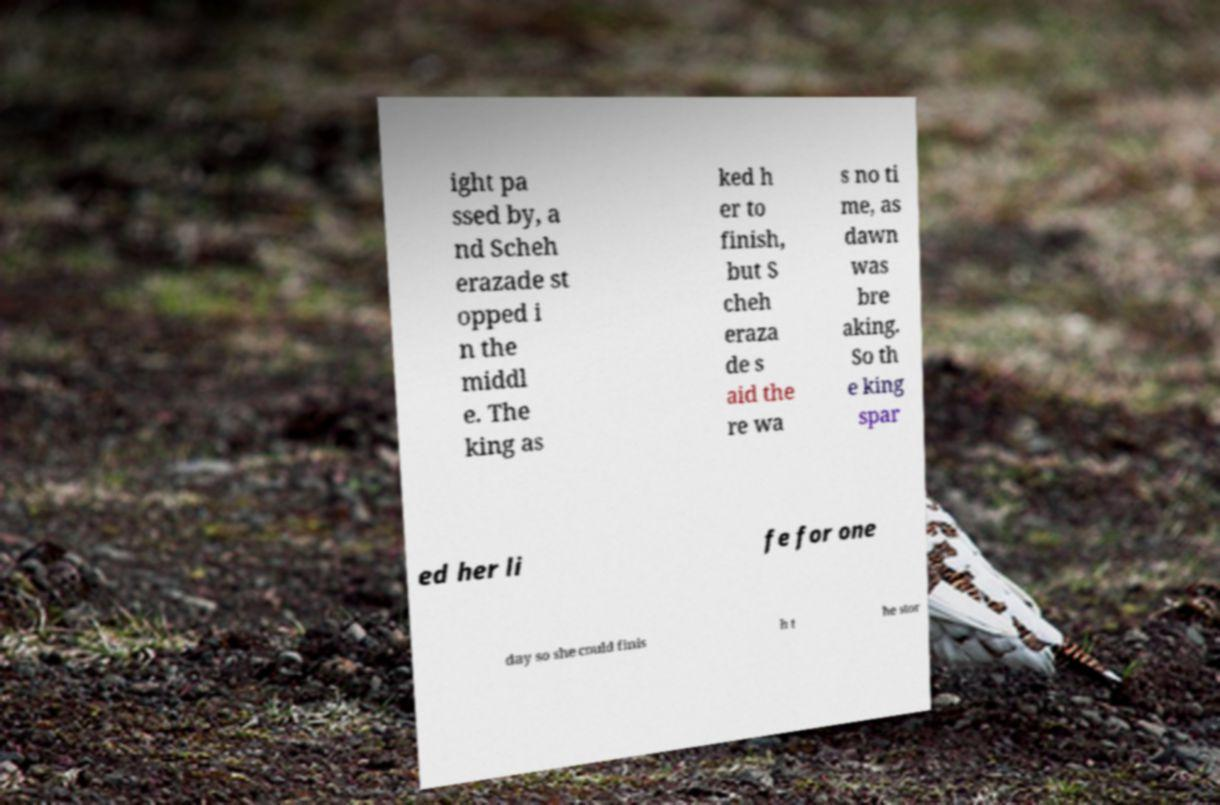Can you read and provide the text displayed in the image?This photo seems to have some interesting text. Can you extract and type it out for me? ight pa ssed by, a nd Scheh erazade st opped i n the middl e. The king as ked h er to finish, but S cheh eraza de s aid the re wa s no ti me, as dawn was bre aking. So th e king spar ed her li fe for one day so she could finis h t he stor 